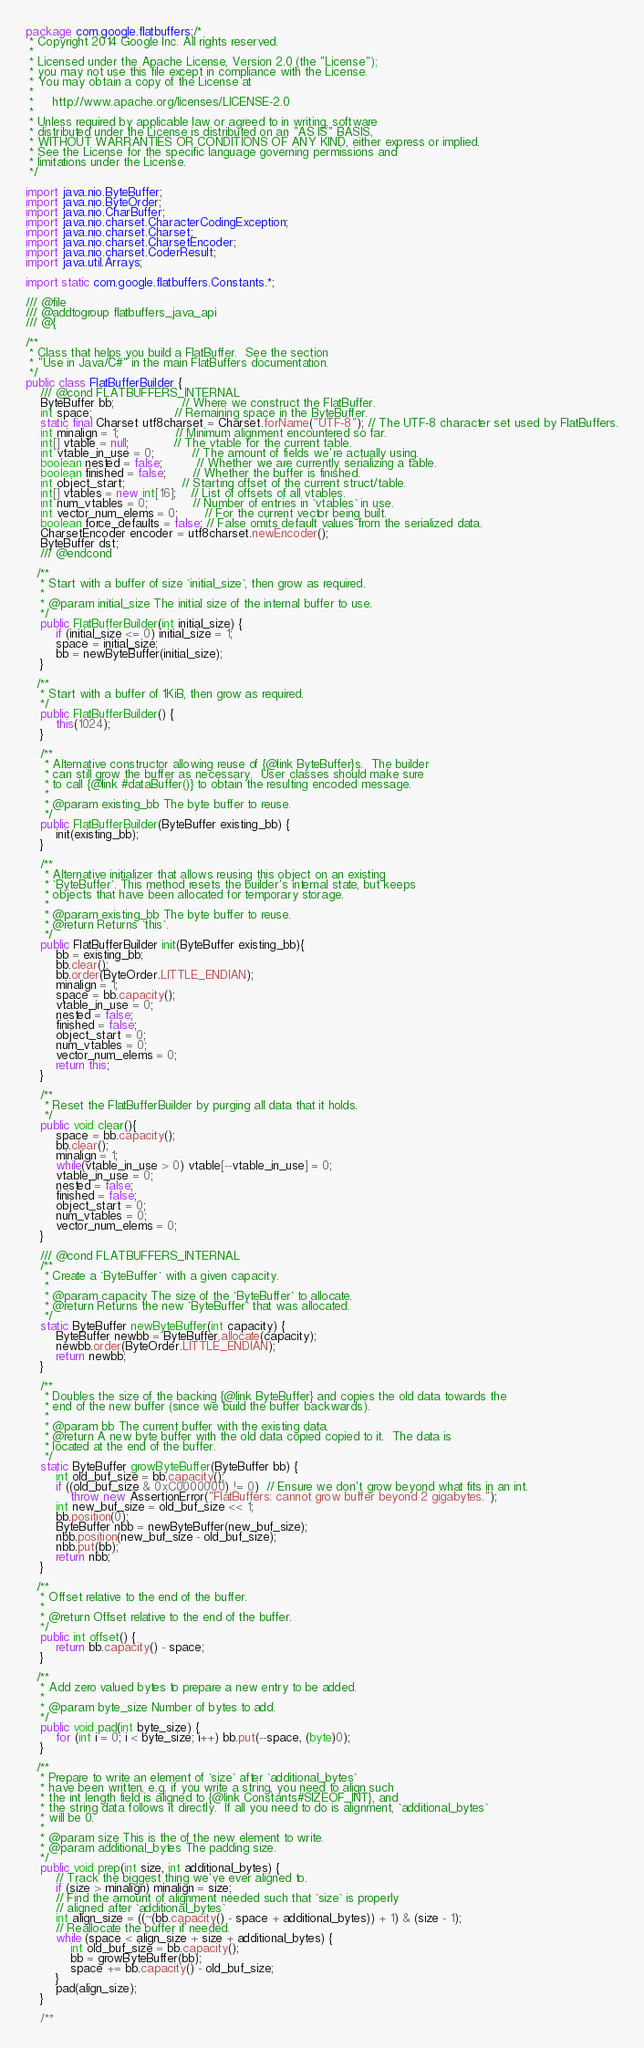Convert code to text. <code><loc_0><loc_0><loc_500><loc_500><_Java_>package com.google.flatbuffers;/*
 * Copyright 2014 Google Inc. All rights reserved.
 *
 * Licensed under the Apache License, Version 2.0 (the "License");
 * you may not use this file except in compliance with the License.
 * You may obtain a copy of the License at
 *
 *     http://www.apache.org/licenses/LICENSE-2.0
 *
 * Unless required by applicable law or agreed to in writing, software
 * distributed under the License is distributed on an "AS IS" BASIS,
 * WITHOUT WARRANTIES OR CONDITIONS OF ANY KIND, either express or implied.
 * See the License for the specific language governing permissions and
 * limitations under the License.
 */

import java.nio.ByteBuffer;
import java.nio.ByteOrder;
import java.nio.CharBuffer;
import java.nio.charset.CharacterCodingException;
import java.nio.charset.Charset;
import java.nio.charset.CharsetEncoder;
import java.nio.charset.CoderResult;
import java.util.Arrays;

import static com.google.flatbuffers.Constants.*;

/// @file
/// @addtogroup flatbuffers_java_api
/// @{

/**
 * Class that helps you build a FlatBuffer.  See the section
 * "Use in Java/C#" in the main FlatBuffers documentation.
 */
public class FlatBufferBuilder {
    /// @cond FLATBUFFERS_INTERNAL
    ByteBuffer bb;                  // Where we construct the FlatBuffer.
    int space;                      // Remaining space in the ByteBuffer.
    static final Charset utf8charset = Charset.forName("UTF-8"); // The UTF-8 character set used by FlatBuffers.
    int minalign = 1;               // Minimum alignment encountered so far.
    int[] vtable = null;            // The vtable for the current table.
    int vtable_in_use = 0;          // The amount of fields we're actually using.
    boolean nested = false;         // Whether we are currently serializing a table.
    boolean finished = false;       // Whether the buffer is finished.
    int object_start;               // Starting offset of the current struct/table.
    int[] vtables = new int[16];    // List of offsets of all vtables.
    int num_vtables = 0;            // Number of entries in `vtables` in use.
    int vector_num_elems = 0;       // For the current vector being built.
    boolean force_defaults = false; // False omits default values from the serialized data.
    CharsetEncoder encoder = utf8charset.newEncoder();
    ByteBuffer dst;
    /// @endcond

   /**
    * Start with a buffer of size `initial_size`, then grow as required.
    *
    * @param initial_size The initial size of the internal buffer to use.
    */
    public FlatBufferBuilder(int initial_size) {
        if (initial_size <= 0) initial_size = 1;
        space = initial_size;
        bb = newByteBuffer(initial_size);
    }

   /**
    * Start with a buffer of 1KiB, then grow as required.
    */
    public FlatBufferBuilder() {
        this(1024);
    }

    /**
     * Alternative constructor allowing reuse of {@link ByteBuffer}s.  The builder
     * can still grow the buffer as necessary.  User classes should make sure
     * to call {@link #dataBuffer()} to obtain the resulting encoded message.
     *
     * @param existing_bb The byte buffer to reuse.
     */
    public FlatBufferBuilder(ByteBuffer existing_bb) {
        init(existing_bb);
    }

    /**
     * Alternative initializer that allows reusing this object on an existing
     * `ByteBuffer`. This method resets the builder's internal state, but keeps
     * objects that have been allocated for temporary storage.
     *
     * @param existing_bb The byte buffer to reuse.
     * @return Returns `this`.
     */
    public FlatBufferBuilder init(ByteBuffer existing_bb){
        bb = existing_bb;
        bb.clear();
        bb.order(ByteOrder.LITTLE_ENDIAN);
        minalign = 1;
        space = bb.capacity();
        vtable_in_use = 0;
        nested = false;
        finished = false;
        object_start = 0;
        num_vtables = 0;
        vector_num_elems = 0;
        return this;
    }

    /**
     * Reset the FlatBufferBuilder by purging all data that it holds.
     */
    public void clear(){
        space = bb.capacity();
        bb.clear();
        minalign = 1;
        while(vtable_in_use > 0) vtable[--vtable_in_use] = 0;
        vtable_in_use = 0;
        nested = false;
        finished = false;
        object_start = 0;
        num_vtables = 0;
        vector_num_elems = 0;
    }

    /// @cond FLATBUFFERS_INTERNAL
    /**
     * Create a `ByteBuffer` with a given capacity.
     *
     * @param capacity The size of the `ByteBuffer` to allocate.
     * @return Returns the new `ByteBuffer` that was allocated.
     */
    static ByteBuffer newByteBuffer(int capacity) {
        ByteBuffer newbb = ByteBuffer.allocate(capacity);
        newbb.order(ByteOrder.LITTLE_ENDIAN);
        return newbb;
    }

    /**
     * Doubles the size of the backing {@link ByteBuffer} and copies the old data towards the
     * end of the new buffer (since we build the buffer backwards).
     *
     * @param bb The current buffer with the existing data.
     * @return A new byte buffer with the old data copied copied to it.  The data is
     * located at the end of the buffer.
     */
    static ByteBuffer growByteBuffer(ByteBuffer bb) {
        int old_buf_size = bb.capacity();
        if ((old_buf_size & 0xC0000000) != 0)  // Ensure we don't grow beyond what fits in an int.
            throw new AssertionError("FlatBuffers: cannot grow buffer beyond 2 gigabytes.");
        int new_buf_size = old_buf_size << 1;
        bb.position(0);
        ByteBuffer nbb = newByteBuffer(new_buf_size);
        nbb.position(new_buf_size - old_buf_size);
        nbb.put(bb);
        return nbb;
    }

   /**
    * Offset relative to the end of the buffer.
    *
    * @return Offset relative to the end of the buffer.
    */
    public int offset() {
        return bb.capacity() - space;
    }

   /**
    * Add zero valued bytes to prepare a new entry to be added.
    *
    * @param byte_size Number of bytes to add.
    */
    public void pad(int byte_size) {
        for (int i = 0; i < byte_size; i++) bb.put(--space, (byte)0);
    }

   /**
    * Prepare to write an element of `size` after `additional_bytes`
    * have been written, e.g. if you write a string, you need to align such
    * the int length field is aligned to {@link Constants#SIZEOF_INT}, and
    * the string data follows it directly.  If all you need to do is alignment, `additional_bytes`
    * will be 0.
    *
    * @param size This is the of the new element to write.
    * @param additional_bytes The padding size.
    */
    public void prep(int size, int additional_bytes) {
        // Track the biggest thing we've ever aligned to.
        if (size > minalign) minalign = size;
        // Find the amount of alignment needed such that `size` is properly
        // aligned after `additional_bytes`
        int align_size = ((~(bb.capacity() - space + additional_bytes)) + 1) & (size - 1);
        // Reallocate the buffer if needed.
        while (space < align_size + size + additional_bytes) {
            int old_buf_size = bb.capacity();
            bb = growByteBuffer(bb);
            space += bb.capacity() - old_buf_size;
        }
        pad(align_size);
    }

    /**</code> 